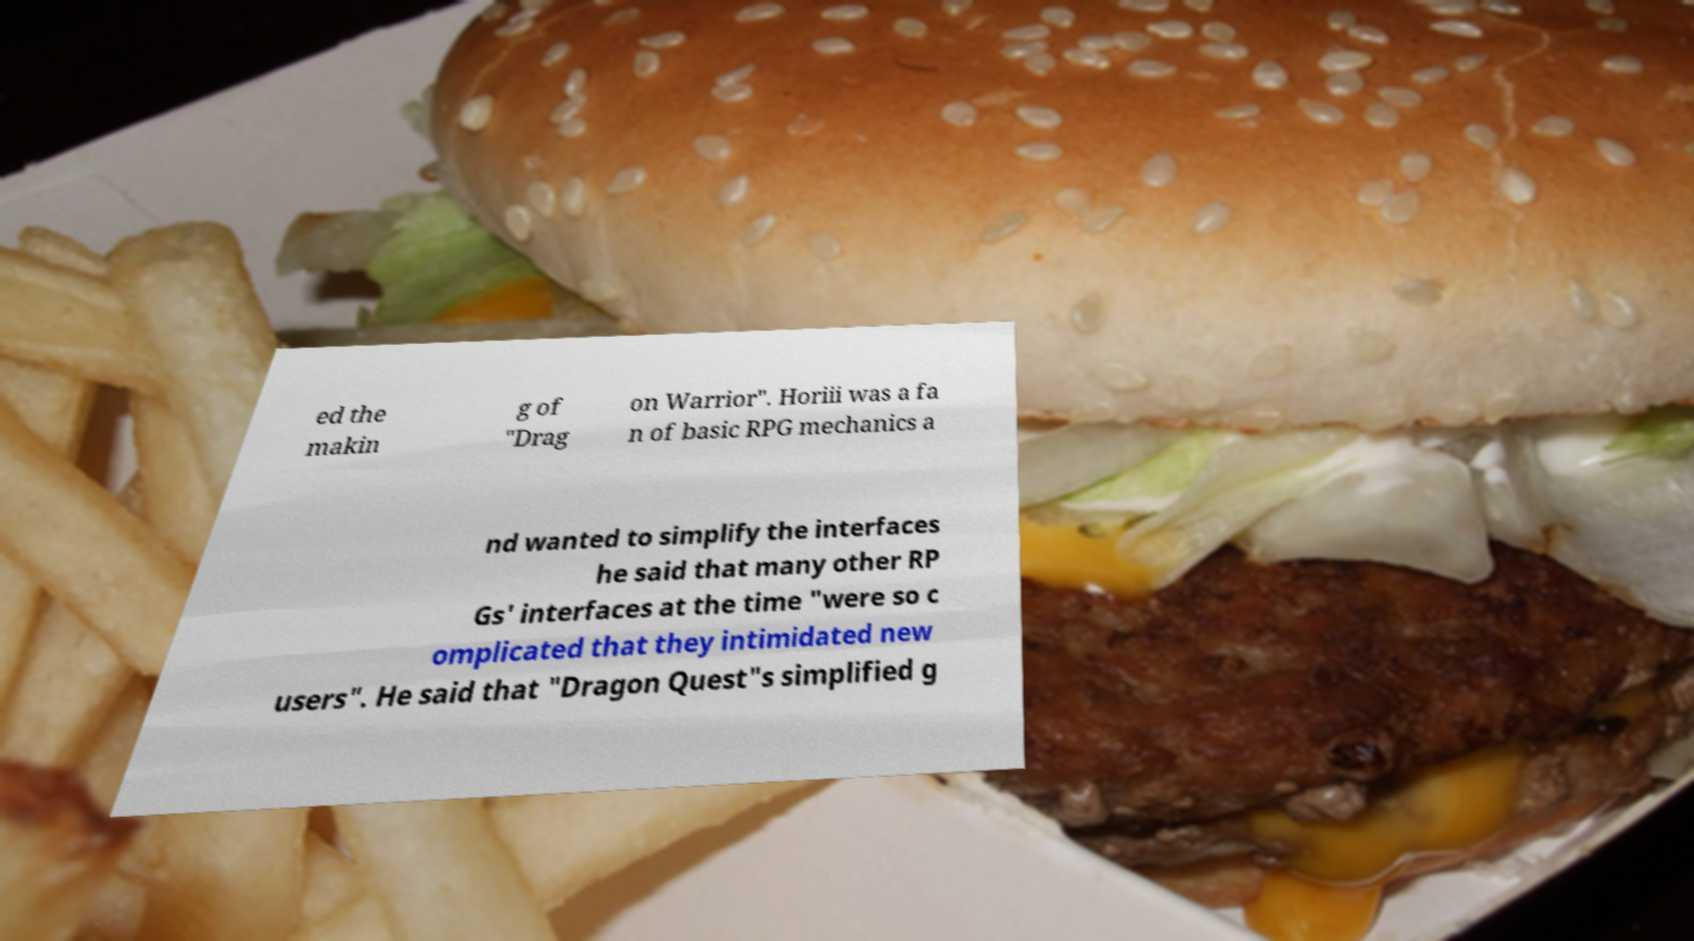Please identify and transcribe the text found in this image. ed the makin g of "Drag on Warrior". Horiii was a fa n of basic RPG mechanics a nd wanted to simplify the interfaces he said that many other RP Gs' interfaces at the time "were so c omplicated that they intimidated new users". He said that "Dragon Quest"s simplified g 